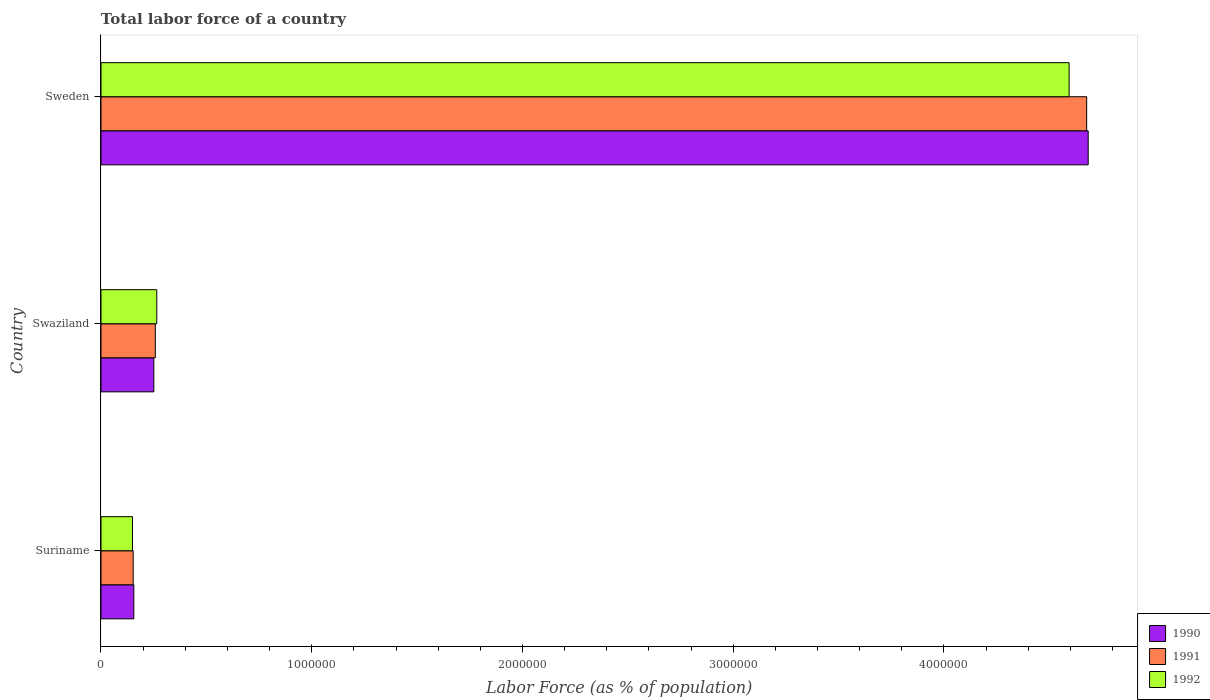Are the number of bars on each tick of the Y-axis equal?
Your answer should be compact. Yes. What is the label of the 2nd group of bars from the top?
Give a very brief answer. Swaziland. What is the percentage of labor force in 1992 in Swaziland?
Your response must be concise. 2.65e+05. Across all countries, what is the maximum percentage of labor force in 1991?
Offer a terse response. 4.68e+06. Across all countries, what is the minimum percentage of labor force in 1990?
Give a very brief answer. 1.56e+05. In which country was the percentage of labor force in 1991 maximum?
Give a very brief answer. Sweden. In which country was the percentage of labor force in 1991 minimum?
Offer a terse response. Suriname. What is the total percentage of labor force in 1992 in the graph?
Give a very brief answer. 5.01e+06. What is the difference between the percentage of labor force in 1992 in Suriname and that in Sweden?
Give a very brief answer. -4.44e+06. What is the difference between the percentage of labor force in 1991 in Suriname and the percentage of labor force in 1990 in Swaziland?
Offer a very short reply. -9.80e+04. What is the average percentage of labor force in 1991 per country?
Provide a short and direct response. 1.70e+06. What is the difference between the percentage of labor force in 1990 and percentage of labor force in 1992 in Swaziland?
Your answer should be very brief. -1.40e+04. In how many countries, is the percentage of labor force in 1991 greater than 4000000 %?
Your answer should be very brief. 1. What is the ratio of the percentage of labor force in 1990 in Swaziland to that in Sweden?
Offer a very short reply. 0.05. Is the percentage of labor force in 1990 in Suriname less than that in Swaziland?
Your response must be concise. Yes. What is the difference between the highest and the second highest percentage of labor force in 1992?
Give a very brief answer. 4.33e+06. What is the difference between the highest and the lowest percentage of labor force in 1990?
Provide a short and direct response. 4.53e+06. In how many countries, is the percentage of labor force in 1991 greater than the average percentage of labor force in 1991 taken over all countries?
Provide a succinct answer. 1. Is the sum of the percentage of labor force in 1990 in Swaziland and Sweden greater than the maximum percentage of labor force in 1992 across all countries?
Give a very brief answer. Yes. Is it the case that in every country, the sum of the percentage of labor force in 1991 and percentage of labor force in 1990 is greater than the percentage of labor force in 1992?
Offer a very short reply. Yes. How many bars are there?
Provide a succinct answer. 9. Are all the bars in the graph horizontal?
Your answer should be compact. Yes. Does the graph contain grids?
Offer a very short reply. No. How are the legend labels stacked?
Your answer should be very brief. Vertical. What is the title of the graph?
Your response must be concise. Total labor force of a country. What is the label or title of the X-axis?
Your response must be concise. Labor Force (as % of population). What is the Labor Force (as % of population) in 1990 in Suriname?
Your answer should be very brief. 1.56e+05. What is the Labor Force (as % of population) of 1991 in Suriname?
Give a very brief answer. 1.53e+05. What is the Labor Force (as % of population) of 1992 in Suriname?
Offer a very short reply. 1.49e+05. What is the Labor Force (as % of population) in 1990 in Swaziland?
Your answer should be very brief. 2.51e+05. What is the Labor Force (as % of population) in 1991 in Swaziland?
Offer a terse response. 2.58e+05. What is the Labor Force (as % of population) of 1992 in Swaziland?
Offer a terse response. 2.65e+05. What is the Labor Force (as % of population) in 1990 in Sweden?
Make the answer very short. 4.68e+06. What is the Labor Force (as % of population) in 1991 in Sweden?
Offer a very short reply. 4.68e+06. What is the Labor Force (as % of population) in 1992 in Sweden?
Your answer should be very brief. 4.59e+06. Across all countries, what is the maximum Labor Force (as % of population) of 1990?
Provide a succinct answer. 4.68e+06. Across all countries, what is the maximum Labor Force (as % of population) in 1991?
Offer a very short reply. 4.68e+06. Across all countries, what is the maximum Labor Force (as % of population) in 1992?
Your response must be concise. 4.59e+06. Across all countries, what is the minimum Labor Force (as % of population) in 1990?
Make the answer very short. 1.56e+05. Across all countries, what is the minimum Labor Force (as % of population) in 1991?
Offer a very short reply. 1.53e+05. Across all countries, what is the minimum Labor Force (as % of population) of 1992?
Your answer should be very brief. 1.49e+05. What is the total Labor Force (as % of population) of 1990 in the graph?
Make the answer very short. 5.09e+06. What is the total Labor Force (as % of population) of 1991 in the graph?
Your answer should be compact. 5.09e+06. What is the total Labor Force (as % of population) of 1992 in the graph?
Ensure brevity in your answer.  5.01e+06. What is the difference between the Labor Force (as % of population) of 1990 in Suriname and that in Swaziland?
Provide a short and direct response. -9.50e+04. What is the difference between the Labor Force (as % of population) in 1991 in Suriname and that in Swaziland?
Your answer should be compact. -1.05e+05. What is the difference between the Labor Force (as % of population) in 1992 in Suriname and that in Swaziland?
Your answer should be very brief. -1.15e+05. What is the difference between the Labor Force (as % of population) of 1990 in Suriname and that in Sweden?
Provide a short and direct response. -4.53e+06. What is the difference between the Labor Force (as % of population) in 1991 in Suriname and that in Sweden?
Your answer should be very brief. -4.52e+06. What is the difference between the Labor Force (as % of population) in 1992 in Suriname and that in Sweden?
Provide a short and direct response. -4.44e+06. What is the difference between the Labor Force (as % of population) of 1990 in Swaziland and that in Sweden?
Ensure brevity in your answer.  -4.43e+06. What is the difference between the Labor Force (as % of population) in 1991 in Swaziland and that in Sweden?
Make the answer very short. -4.42e+06. What is the difference between the Labor Force (as % of population) of 1992 in Swaziland and that in Sweden?
Your answer should be compact. -4.33e+06. What is the difference between the Labor Force (as % of population) in 1990 in Suriname and the Labor Force (as % of population) in 1991 in Swaziland?
Your answer should be very brief. -1.02e+05. What is the difference between the Labor Force (as % of population) in 1990 in Suriname and the Labor Force (as % of population) in 1992 in Swaziland?
Provide a short and direct response. -1.09e+05. What is the difference between the Labor Force (as % of population) of 1991 in Suriname and the Labor Force (as % of population) of 1992 in Swaziland?
Your response must be concise. -1.12e+05. What is the difference between the Labor Force (as % of population) in 1990 in Suriname and the Labor Force (as % of population) in 1991 in Sweden?
Keep it short and to the point. -4.52e+06. What is the difference between the Labor Force (as % of population) in 1990 in Suriname and the Labor Force (as % of population) in 1992 in Sweden?
Provide a succinct answer. -4.44e+06. What is the difference between the Labor Force (as % of population) of 1991 in Suriname and the Labor Force (as % of population) of 1992 in Sweden?
Provide a short and direct response. -4.44e+06. What is the difference between the Labor Force (as % of population) in 1990 in Swaziland and the Labor Force (as % of population) in 1991 in Sweden?
Give a very brief answer. -4.43e+06. What is the difference between the Labor Force (as % of population) of 1990 in Swaziland and the Labor Force (as % of population) of 1992 in Sweden?
Offer a terse response. -4.34e+06. What is the difference between the Labor Force (as % of population) in 1991 in Swaziland and the Labor Force (as % of population) in 1992 in Sweden?
Make the answer very short. -4.34e+06. What is the average Labor Force (as % of population) in 1990 per country?
Give a very brief answer. 1.70e+06. What is the average Labor Force (as % of population) in 1991 per country?
Offer a terse response. 1.70e+06. What is the average Labor Force (as % of population) of 1992 per country?
Keep it short and to the point. 1.67e+06. What is the difference between the Labor Force (as % of population) of 1990 and Labor Force (as % of population) of 1991 in Suriname?
Provide a succinct answer. 2991. What is the difference between the Labor Force (as % of population) of 1990 and Labor Force (as % of population) of 1992 in Suriname?
Your answer should be compact. 6341. What is the difference between the Labor Force (as % of population) of 1991 and Labor Force (as % of population) of 1992 in Suriname?
Your response must be concise. 3350. What is the difference between the Labor Force (as % of population) in 1990 and Labor Force (as % of population) in 1991 in Swaziland?
Offer a very short reply. -7022. What is the difference between the Labor Force (as % of population) of 1990 and Labor Force (as % of population) of 1992 in Swaziland?
Give a very brief answer. -1.40e+04. What is the difference between the Labor Force (as % of population) in 1991 and Labor Force (as % of population) in 1992 in Swaziland?
Offer a terse response. -6972. What is the difference between the Labor Force (as % of population) of 1990 and Labor Force (as % of population) of 1991 in Sweden?
Your response must be concise. 7307. What is the difference between the Labor Force (as % of population) in 1990 and Labor Force (as % of population) in 1992 in Sweden?
Your answer should be very brief. 9.06e+04. What is the difference between the Labor Force (as % of population) of 1991 and Labor Force (as % of population) of 1992 in Sweden?
Ensure brevity in your answer.  8.33e+04. What is the ratio of the Labor Force (as % of population) in 1990 in Suriname to that in Swaziland?
Offer a very short reply. 0.62. What is the ratio of the Labor Force (as % of population) in 1991 in Suriname to that in Swaziland?
Ensure brevity in your answer.  0.59. What is the ratio of the Labor Force (as % of population) in 1992 in Suriname to that in Swaziland?
Your answer should be very brief. 0.56. What is the ratio of the Labor Force (as % of population) in 1991 in Suriname to that in Sweden?
Your answer should be very brief. 0.03. What is the ratio of the Labor Force (as % of population) in 1992 in Suriname to that in Sweden?
Ensure brevity in your answer.  0.03. What is the ratio of the Labor Force (as % of population) in 1990 in Swaziland to that in Sweden?
Offer a terse response. 0.05. What is the ratio of the Labor Force (as % of population) in 1991 in Swaziland to that in Sweden?
Offer a very short reply. 0.06. What is the ratio of the Labor Force (as % of population) of 1992 in Swaziland to that in Sweden?
Offer a terse response. 0.06. What is the difference between the highest and the second highest Labor Force (as % of population) in 1990?
Give a very brief answer. 4.43e+06. What is the difference between the highest and the second highest Labor Force (as % of population) of 1991?
Your response must be concise. 4.42e+06. What is the difference between the highest and the second highest Labor Force (as % of population) in 1992?
Your answer should be very brief. 4.33e+06. What is the difference between the highest and the lowest Labor Force (as % of population) of 1990?
Keep it short and to the point. 4.53e+06. What is the difference between the highest and the lowest Labor Force (as % of population) of 1991?
Keep it short and to the point. 4.52e+06. What is the difference between the highest and the lowest Labor Force (as % of population) of 1992?
Give a very brief answer. 4.44e+06. 